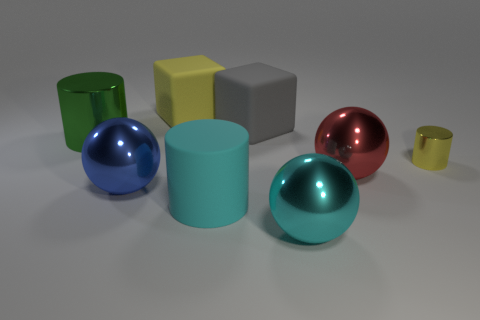Add 1 blue spheres. How many objects exist? 9 Subtract all cylinders. How many objects are left? 5 Subtract 0 green blocks. How many objects are left? 8 Subtract all small yellow metallic objects. Subtract all yellow cylinders. How many objects are left? 6 Add 6 small shiny cylinders. How many small shiny cylinders are left? 7 Add 1 shiny objects. How many shiny objects exist? 6 